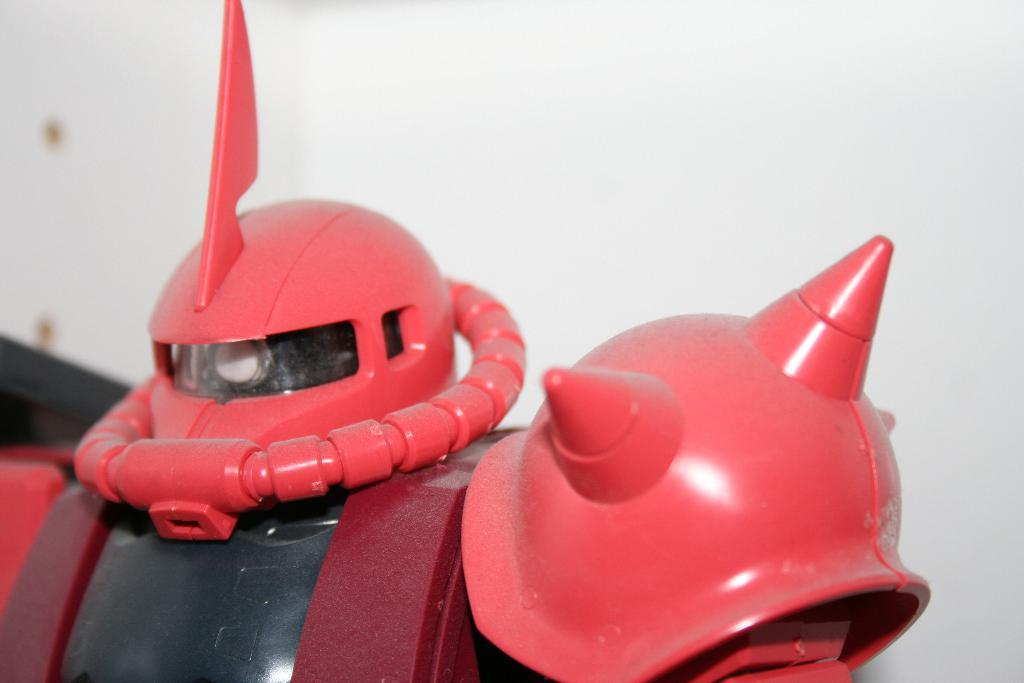What is the main subject of the image? There is a robot in the image. What can be seen in the background of the image? There is a wall in the background of the image. How many lizards are crawling on the robot in the image? There are no lizards present in the image; it features a robot and a wall in the background. What type of bone can be seen attached to the robot in the image? There is no bone present in the image; it features a robot and a wall in the background. 